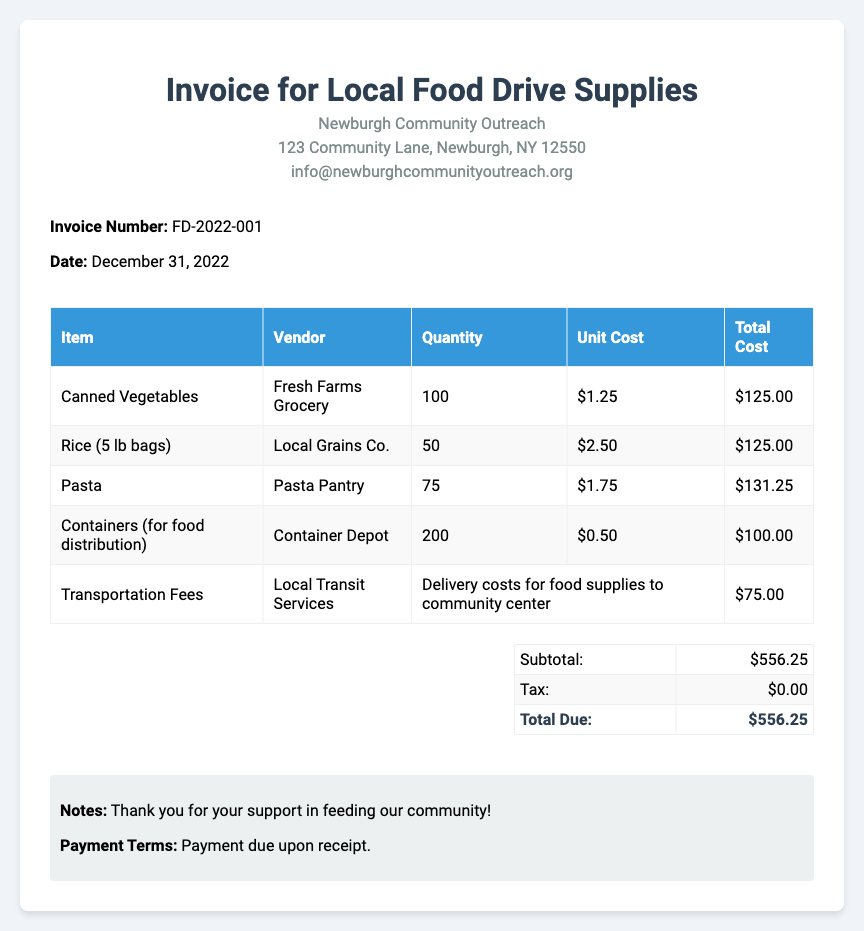What is the invoice number? The invoice number is specified in the document and is FD-2022-001.
Answer: FD-2022-001 What is the date of the invoice? The date of the invoice is presented in the document as December 31, 2022.
Answer: December 31, 2022 How many canned vegetables were purchased? The document lists that 100 units of canned vegetables were purchased.
Answer: 100 What was the total cost for rice? The total cost for rice is calculated in the document as $125.00.
Answer: $125.00 What is the subtotal amount given in the summary? The subtotal amount is clearly listed in the summary as $556.25.
Answer: $556.25 What vendor supplied the containers? The document states that the vendor for the containers is Container Depot.
Answer: Container Depot How much was spent on transportation fees? The document shows that transportation fees amount to $75.00.
Answer: $75.00 What are the payment terms? The document notes that payment is due upon receipt.
Answer: Payment due upon receipt What is the total due for the invoice? The total due is summarized in the document as $556.25.
Answer: $556.25 